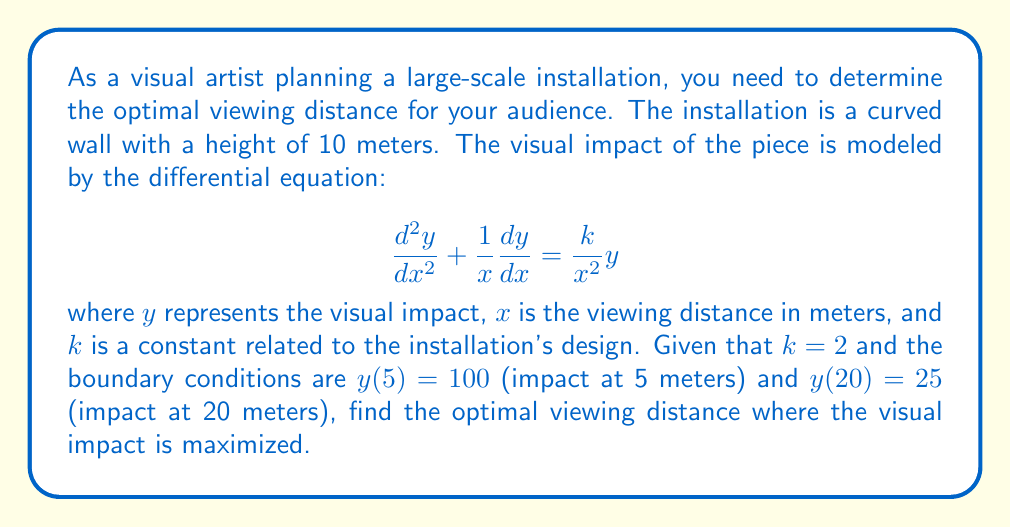Give your solution to this math problem. To solve this problem, we need to follow these steps:

1) First, we recognize this as a Euler-Cauchy equation. The general solution for this type of equation when $k = 2$ is:

   $$y = C_1x + C_2x\ln(x)$$

2) We need to find $C_1$ and $C_2$ using the boundary conditions:

   At $x = 5$: $100 = 5C_1 + 5C_2\ln(5)$
   At $x = 20$: $25 = 20C_1 + 20C_2\ln(20)$

3) Solving this system of equations:

   $20 = C_1 + C_2\ln(5)$
   $1.25 = C_1 + C_2\ln(20)$

   Subtracting these equations:

   $18.75 = C_2(\ln(5) - \ln(20))$
   $C_2 = -\frac{18.75}{\ln(4)} \approx -13.5416$

   Substituting back:

   $C_1 = 20 + 13.5416\ln(5) \approx 41.7843$

4) Now our solution is:

   $$y = 41.7843x - 13.5416x\ln(x)$$

5) To find the maximum impact, we differentiate and set to zero:

   $$\frac{dy}{dx} = 41.7843 - 13.5416(\ln(x) + 1) = 0$$

6) Solving this equation:

   $$\ln(x) + 1 = \frac{41.7843}{13.5416} \approx 3.0856$$
   $$\ln(x) \approx 2.0856$$
   $$x \approx e^{2.0856} \approx 8.05$$

7) We can confirm this is a maximum by checking the second derivative is negative at this point.

Therefore, the optimal viewing distance is approximately 8.05 meters.
Answer: The optimal viewing distance for maximum visual impact is approximately 8.05 meters. 